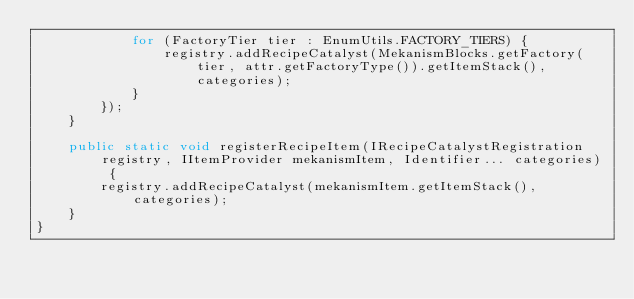Convert code to text. <code><loc_0><loc_0><loc_500><loc_500><_Java_>            for (FactoryTier tier : EnumUtils.FACTORY_TIERS) {
                registry.addRecipeCatalyst(MekanismBlocks.getFactory(tier, attr.getFactoryType()).getItemStack(), categories);
            }
        });
    }

    public static void registerRecipeItem(IRecipeCatalystRegistration registry, IItemProvider mekanismItem, Identifier... categories) {
        registry.addRecipeCatalyst(mekanismItem.getItemStack(), categories);
    }
}</code> 